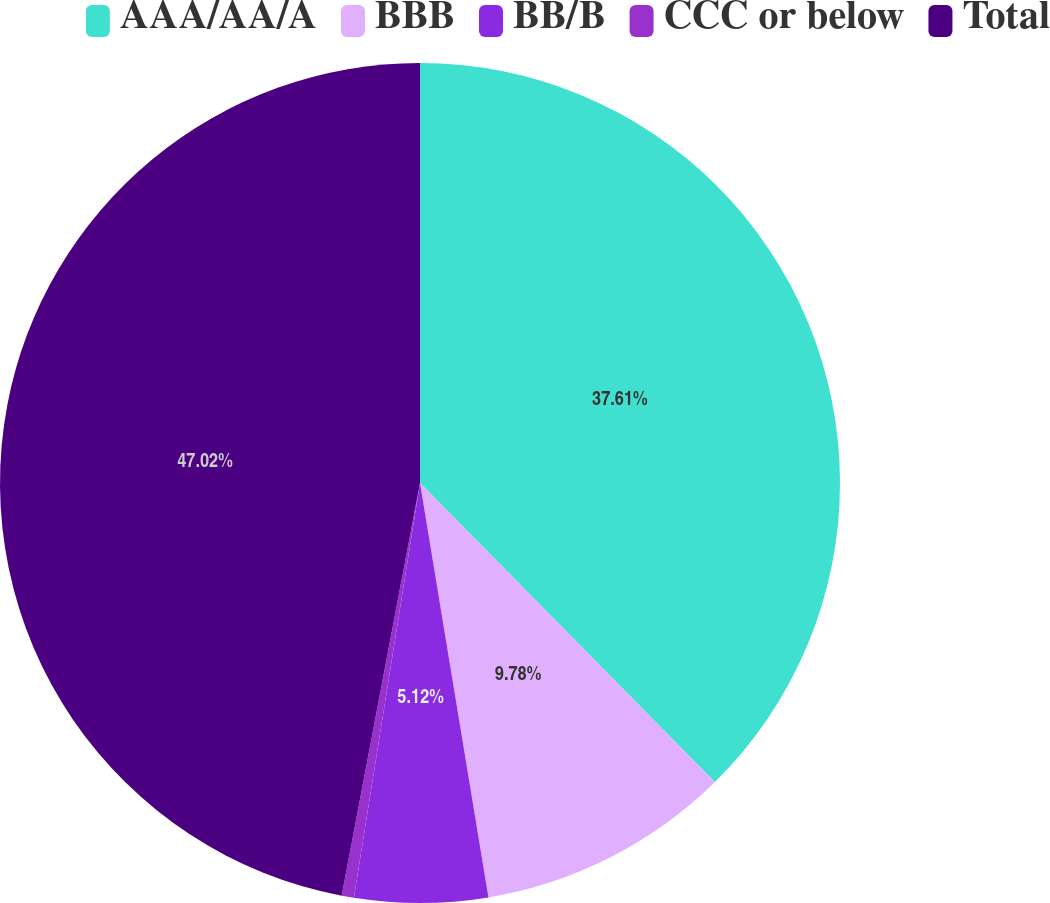<chart> <loc_0><loc_0><loc_500><loc_500><pie_chart><fcel>AAA/AA/A<fcel>BBB<fcel>BB/B<fcel>CCC or below<fcel>Total<nl><fcel>37.61%<fcel>9.78%<fcel>5.12%<fcel>0.47%<fcel>47.01%<nl></chart> 